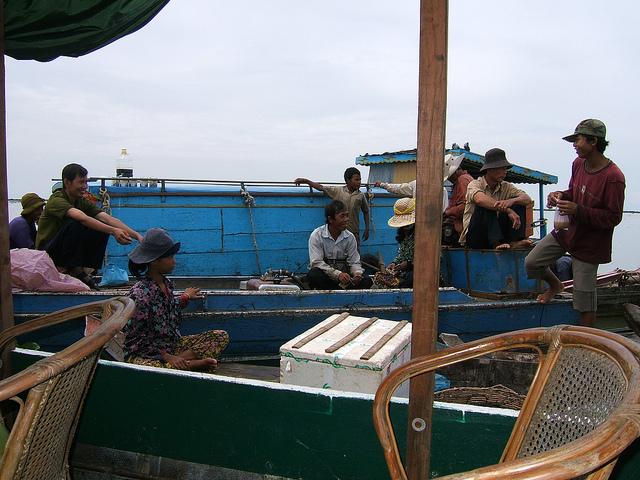How many people wearing hats?
Give a very brief answer. 6. What are the chairs made of?
Concise answer only. Wood. Is this a fishing boat?
Keep it brief. Yes. 